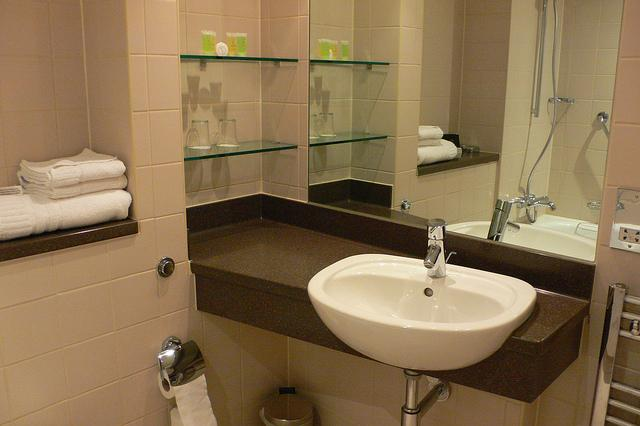What happens if you pull the lever in the middle of the photo?

Choices:
A) nothing
B) water comes
C) soda comes
D) air comes water comes 